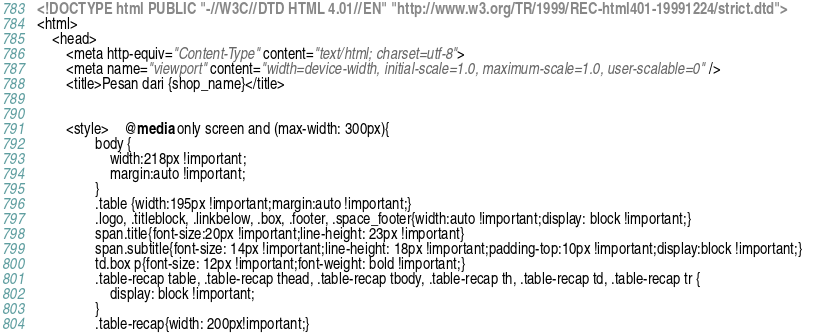<code> <loc_0><loc_0><loc_500><loc_500><_HTML_><!DOCTYPE html PUBLIC "-//W3C//DTD HTML 4.01//EN" "http://www.w3.org/TR/1999/REC-html401-19991224/strict.dtd">
<html>
	<head>
		<meta http-equiv="Content-Type" content="text/html; charset=utf-8">
		<meta name="viewport" content="width=device-width, initial-scale=1.0, maximum-scale=1.0, user-scalable=0" />
		<title>Pesan dari {shop_name}</title>
		
		
		<style>	@media only screen and (max-width: 300px){ 
				body {
					width:218px !important;
					margin:auto !important;
				}
				.table {width:195px !important;margin:auto !important;}
				.logo, .titleblock, .linkbelow, .box, .footer, .space_footer{width:auto !important;display: block !important;}		
				span.title{font-size:20px !important;line-height: 23px !important}
				span.subtitle{font-size: 14px !important;line-height: 18px !important;padding-top:10px !important;display:block !important;}		
				td.box p{font-size: 12px !important;font-weight: bold !important;}
				.table-recap table, .table-recap thead, .table-recap tbody, .table-recap th, .table-recap td, .table-recap tr { 
					display: block !important; 
				}
				.table-recap{width: 200px!important;}</code> 